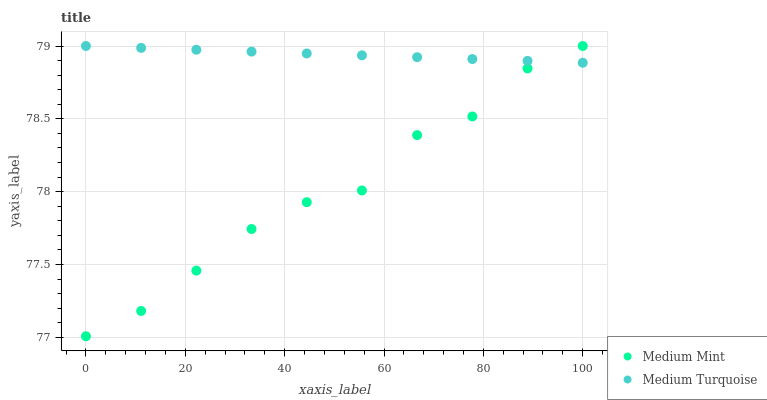Does Medium Mint have the minimum area under the curve?
Answer yes or no. Yes. Does Medium Turquoise have the maximum area under the curve?
Answer yes or no. Yes. Does Medium Turquoise have the minimum area under the curve?
Answer yes or no. No. Is Medium Turquoise the smoothest?
Answer yes or no. Yes. Is Medium Mint the roughest?
Answer yes or no. Yes. Is Medium Turquoise the roughest?
Answer yes or no. No. Does Medium Mint have the lowest value?
Answer yes or no. Yes. Does Medium Turquoise have the lowest value?
Answer yes or no. No. Does Medium Turquoise have the highest value?
Answer yes or no. Yes. Does Medium Mint intersect Medium Turquoise?
Answer yes or no. Yes. Is Medium Mint less than Medium Turquoise?
Answer yes or no. No. Is Medium Mint greater than Medium Turquoise?
Answer yes or no. No. 